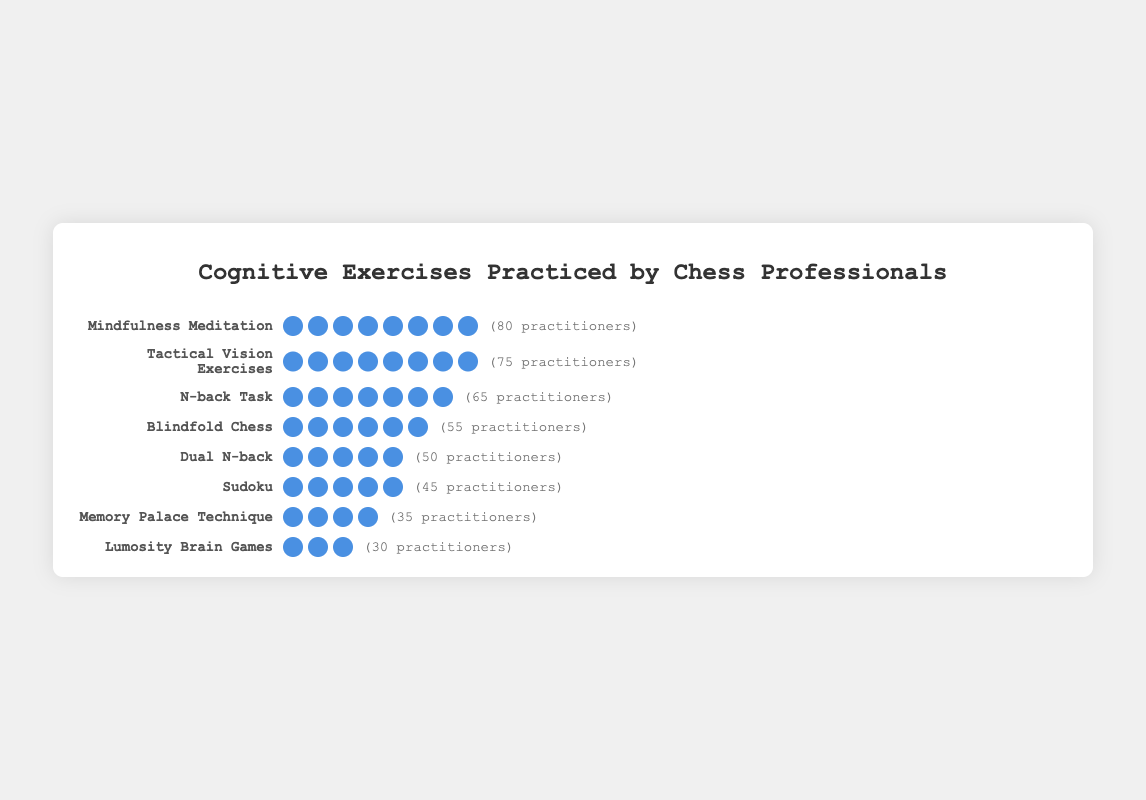Which cognitive exercise has the highest number of practitioners? By examining the plot, we can see that "Mindfulness Meditation" has the most icons, which signifies it has the highest number of practitioners.
Answer: Mindfulness Meditation Which cognitive exercise has the fewest practitioners? The exercise with the fewest icons, indicating the fewest practitioners, is "Lumosity Brain Games."
Answer: Lumosity Brain Games How many practitioners practice "Blindfold Chess"? By counting the icons next to "Blindfold Chess," we see there are 55 practitioners.
Answer: 55 How many more practitioners practice "Mindfulness Meditation" than "Sudoku"? "Mindfulness Meditation" has 80 practitioners and "Sudoku" has 45. The difference is 80 - 45.
Answer: 35 Which two cognitive exercises have the most similar number of practitioners? "Dual N-back" has 50 practitioners and "Sudoku" has 45 practitioners, which are the most similar in number.
Answer: Dual N-back and Sudoku What is the combined total of practitioners who practice either "N-back Task" or "Dual N-back"? The "N-back Task" has 65 practitioners, and "Dual N-back" has 50. Adding these together, 65 + 50.
Answer: 115 Is "Tactical Vision Exercises" practiced by more people than "Blindfold Chess"? By comparing the number of icons, "Tactical Vision Exercises" has 75 practitioners while "Blindfold Chess" has 55.
Answer: Yes Rank the top three cognitive exercises with the highest number of practitioners. The exercises with the highest number of icons are "Mindfulness Meditation" (80), "Tactical Vision Exercises" (75), and "N-back Task" (65).
Answer: Mindfulness Meditation, Tactical Vision Exercises, N-back Task What percentage of practitioners engage in "Memory Palace Technique" out of the total number listed? First, add the total practitioners across all exercises: 80 + 65 + 50 + 45 + 35 + 30 + 75 + 55 = 435. "Memory Palace Technique" has 35 practitioners. The percentage is (35/435) * 100.
Answer: 8.05% Which has more practitioners: The sum of "Lumosity Brain Games" and "Memory Palace Technique" or "Dual N-back"? "Lumosity Brain Games" plus "Memory Palace Technique" is 30 + 35 = 65, while "Dual N-back" has 50 practitioners.
Answer: Lumosity Brain Games and Memory Palace Technique 